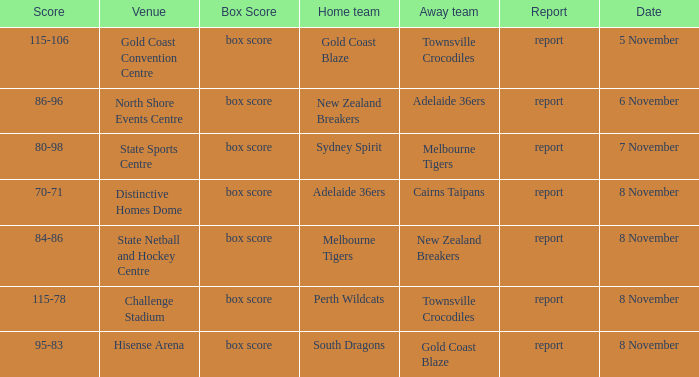Who was the home team at Gold Coast Convention Centre? Gold Coast Blaze. 